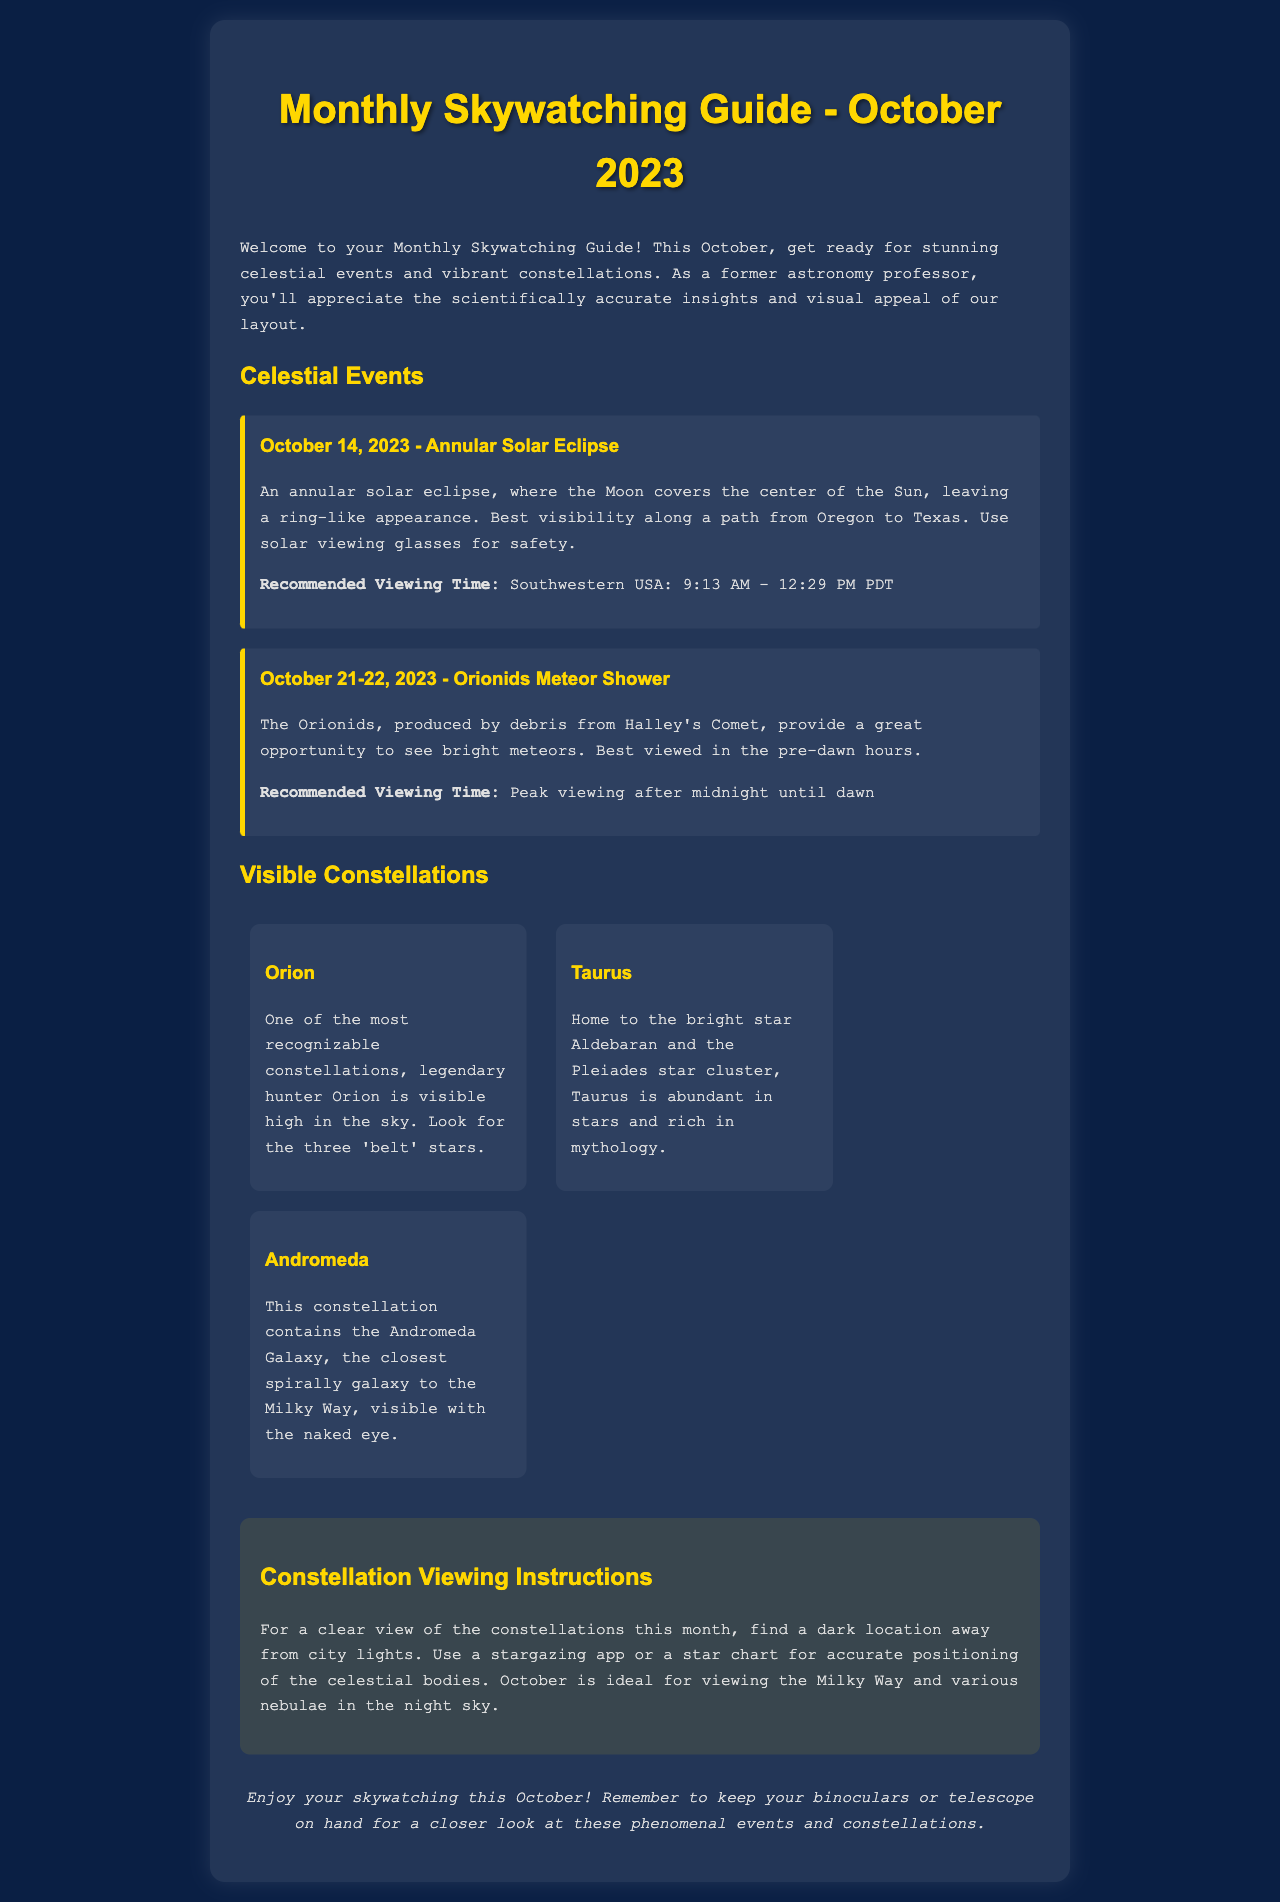What celestial event occurs on October 14, 2023? The event is an annular solar eclipse, where the Moon covers the center of the Sun, leaving a ring-like appearance.
Answer: annular solar eclipse What time is the best viewing for the annular solar eclipse? The recommended viewing time for the annular solar eclipse is specified for the Southwestern USA from 9:13 AM to 12:29 PM PDT.
Answer: 9:13 AM - 12:29 PM PDT What meteor shower peaks on October 21-22, 2023? The document states that the Orionids meteor shower peaks on these dates, produced by debris from Halley's Comet.
Answer: Orionids Which constellation is described as having a "belt"? Orion is described as one of the most recognizable constellations, with three 'belt' stars.
Answer: Orion What is the closest galaxy to the Milky Way mentioned in the guide? The Andromeda Galaxy is noted as the closest spiral galaxy to the Milky Way.
Answer: Andromeda Galaxy What should one use for constellation positioning? The document recommends using a stargazing app or a star chart for accurate positioning of the celestial bodies.
Answer: stargazing app or star chart Which star cluster is located in the Taurus constellation? The Pleiades star cluster is mentioned as being located in the Taurus constellation.
Answer: Pleiades When are the best viewing hours for the Orionids meteor shower? The document indicates that the best viewing time for the Orionids meteor shower is from after midnight until dawn.
Answer: after midnight until dawn What color is the background of the document? The body background color is specified as '#0a1f44', a dark blue color.
Answer: dark blue 